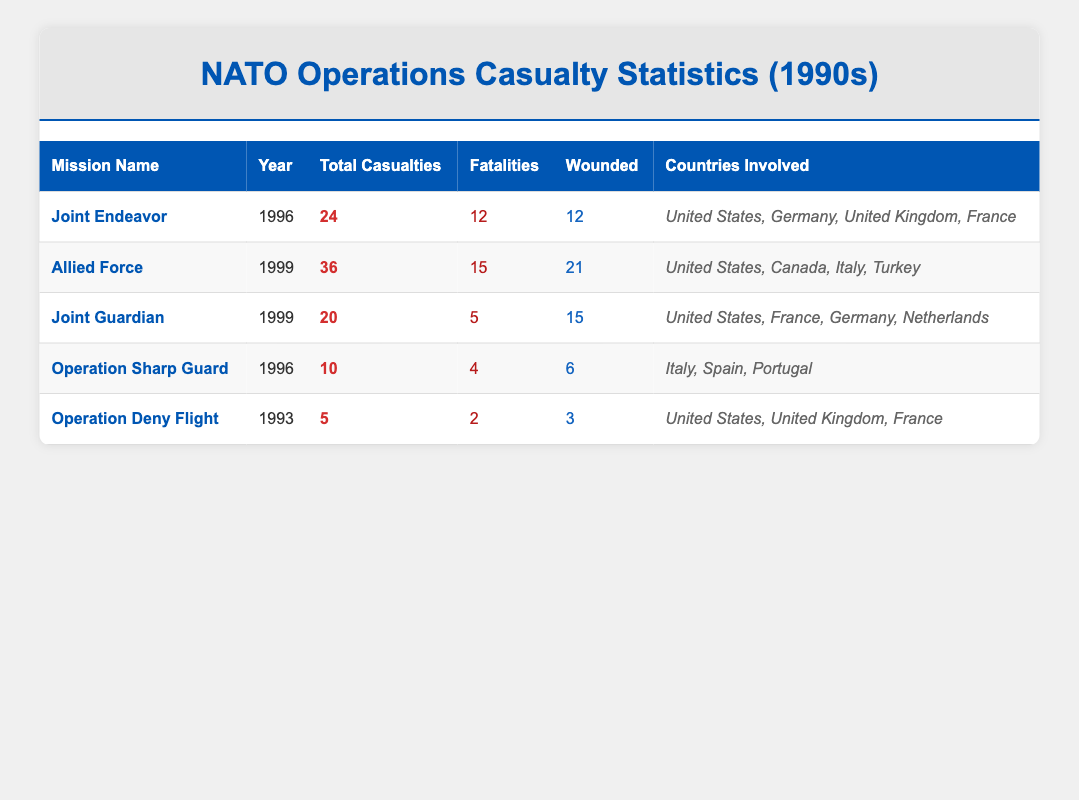What is the total number of casualties in the "Allied Force" mission? The table shows that the total casualties for the "Allied Force" mission in 1999 are 36.
Answer: 36 How many fatalities occurred during the "Joint Endeavor" mission? According to the table, the "Joint Endeavor" mission had 12 fatalities recorded in 1996.
Answer: 12 Which NATO operation had the highest number of wounded individuals? The "Allied Force" mission had the highest number of wounded individuals, totaling 21. This can be found by comparing the wounded numbers from all missions listed in the table.
Answer: 21 What is the difference between total casualties of "Operation Sharp Guard" and "Operation Deny Flight"? "Operation Sharp Guard" had 10 total casualties, while "Operation Deny Flight" had 5. Thus, the difference is calculated as 10 - 5 = 5.
Answer: 5 Did the "Joint Guardian" mission have more fatalities than the "Operation Sharp Guard"? The "Joint Guardian" mission recorded 5 fatalities, whereas "Operation Sharp Guard" had 4 fatalities. Since 5 is greater than 4, the answer is yes.
Answer: Yes What was the average number of total casualties across all missions? The total casualties of all the missions are 24 (Joint Endeavor) + 36 (Allied Force) + 20 (Joint Guardian) + 10 (Operation Sharp Guard) + 5 (Operation Deny Flight) = 95. There are 5 missions, so the average is 95 / 5 = 19.
Answer: 19 Which year had the least number of total casualties recorded? In 1993, the "Operation Deny Flight" had the least total casualties, recorded at 5. Comparing all years in the table, this is the lowest number.
Answer: 5 How many countries were involved in "Operation Sharp Guard"? The table indicates that "Operation Sharp Guard" involved three countries: Italy, Spain, and Portugal. This is derived from the list of countries mentioned in the respective row.
Answer: 3 Was the total number of casualties in the year 1999 higher than in 1996? In 1999, the total casualties from "Allied Force" (36) and "Joint Guardian" (20) sum up to 56. In 1996, the total casualties from "Joint Endeavor" (24) and "Operation Sharp Guard" (10) sum up to 34. Comparing 56 with 34 shows that 1999 had more casualties.
Answer: Yes 